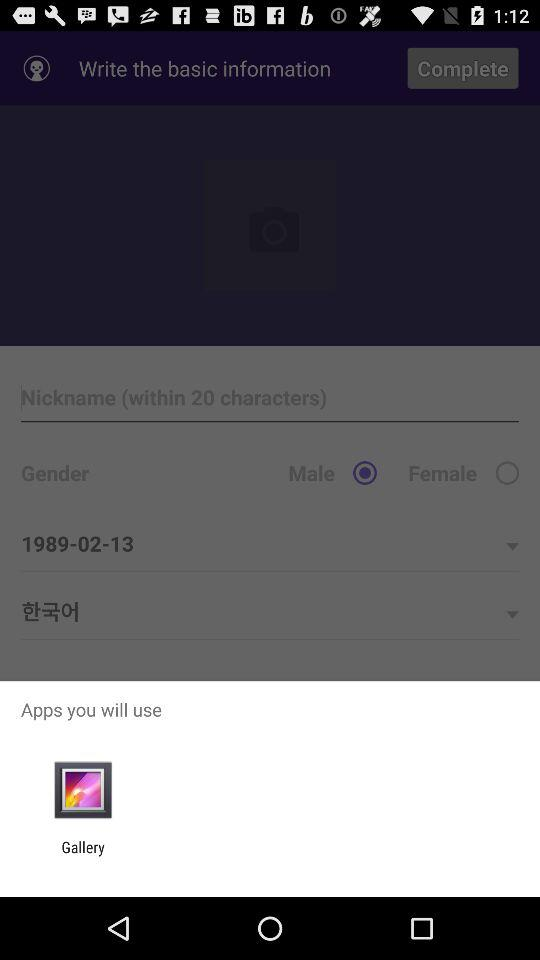What application will be used? The application that will be used is "Gallery". 